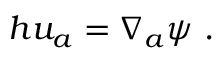Convert formula to latex. <formula><loc_0><loc_0><loc_500><loc_500>h u _ { a } = \nabla _ { a } \psi .</formula> 